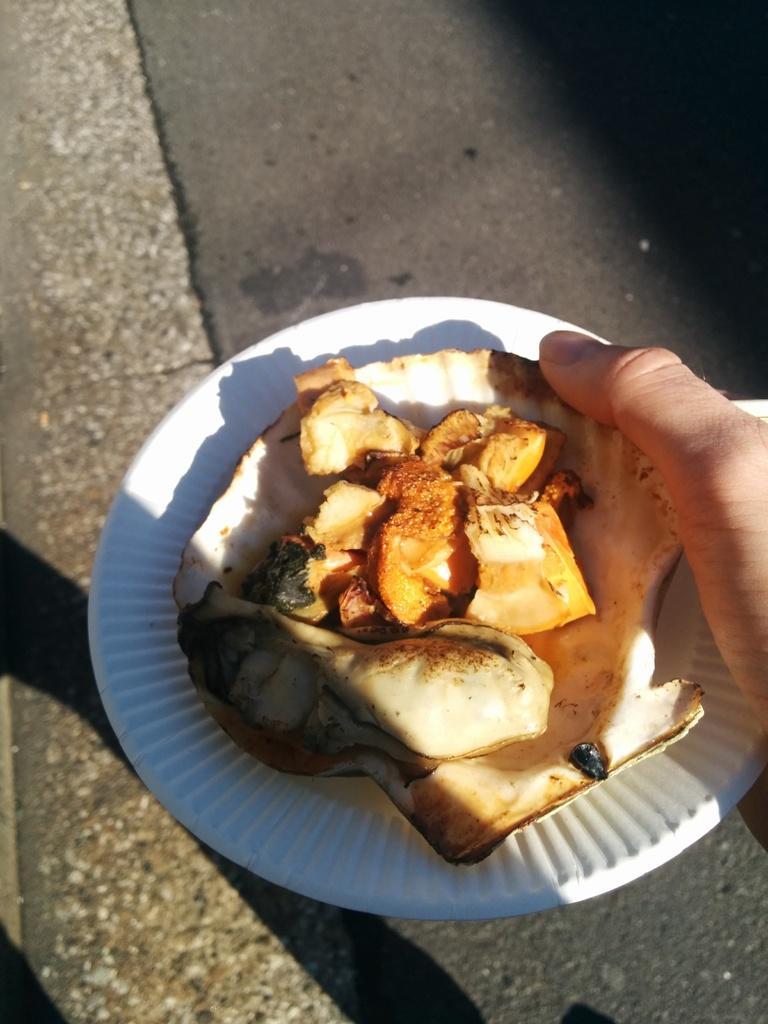Could you give a brief overview of what you see in this image? In this image we can see a person's hand holding a plate with food item. At the bottom of the image there is road. 